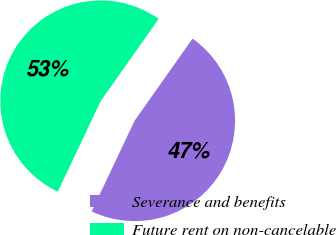Convert chart. <chart><loc_0><loc_0><loc_500><loc_500><pie_chart><fcel>Severance and benefits<fcel>Future rent on non-cancelable<nl><fcel>47.26%<fcel>52.74%<nl></chart> 